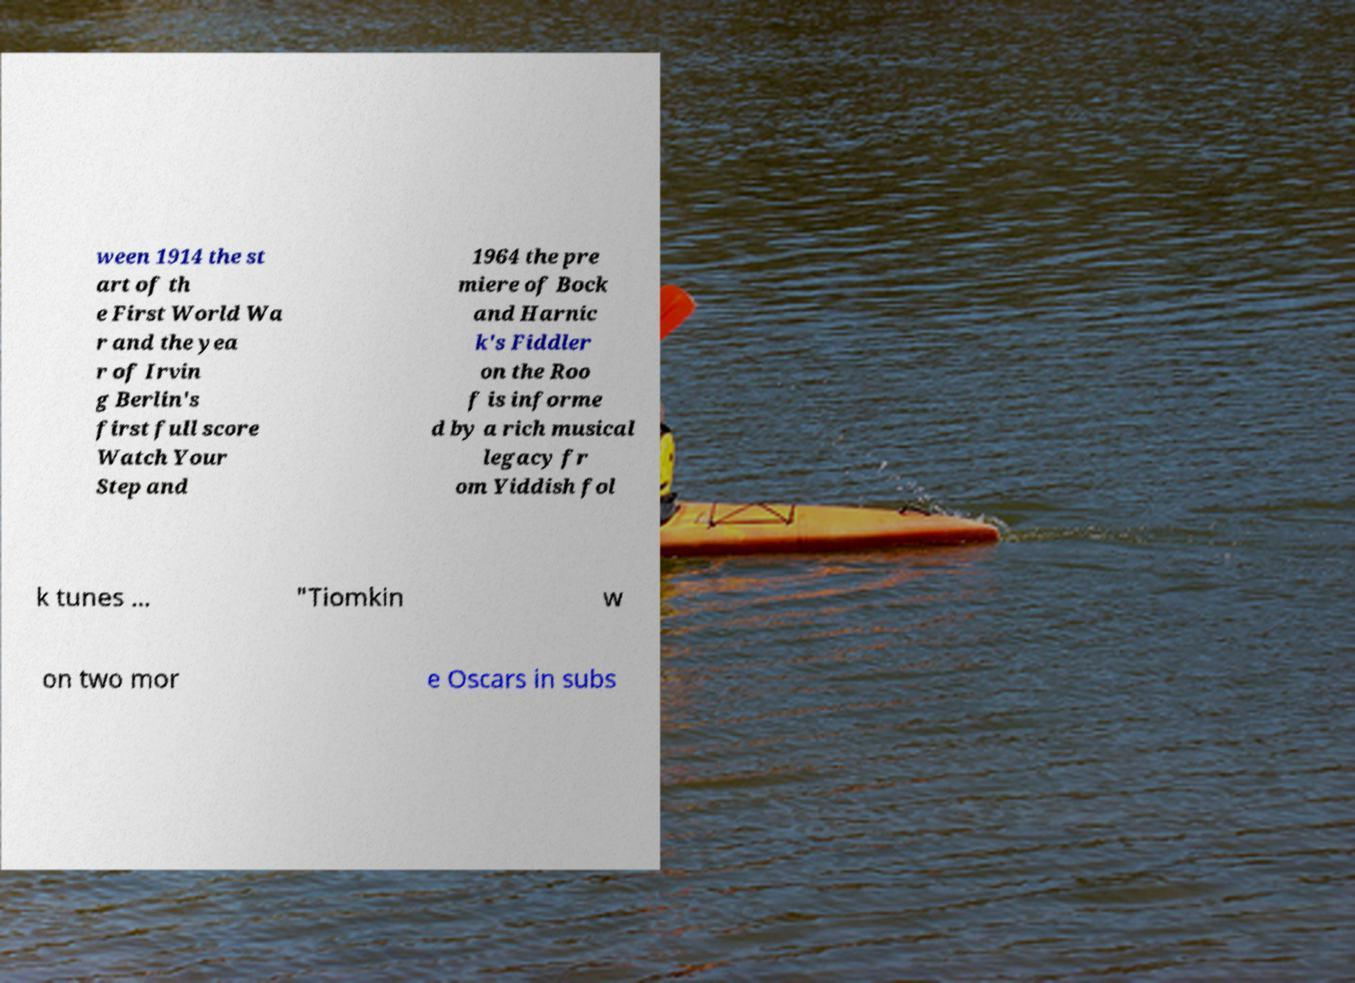There's text embedded in this image that I need extracted. Can you transcribe it verbatim? ween 1914 the st art of th e First World Wa r and the yea r of Irvin g Berlin's first full score Watch Your Step and 1964 the pre miere of Bock and Harnic k's Fiddler on the Roo f is informe d by a rich musical legacy fr om Yiddish fol k tunes ... "Tiomkin w on two mor e Oscars in subs 